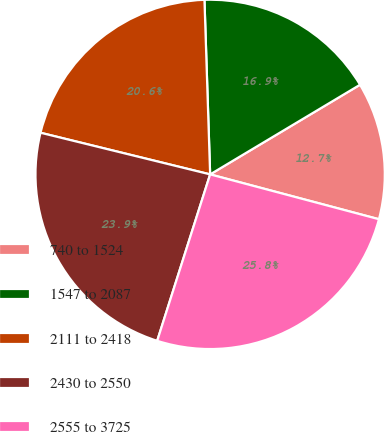Convert chart. <chart><loc_0><loc_0><loc_500><loc_500><pie_chart><fcel>740 to 1524<fcel>1547 to 2087<fcel>2111 to 2418<fcel>2430 to 2550<fcel>2555 to 3725<nl><fcel>12.71%<fcel>16.94%<fcel>20.65%<fcel>23.93%<fcel>25.77%<nl></chart> 